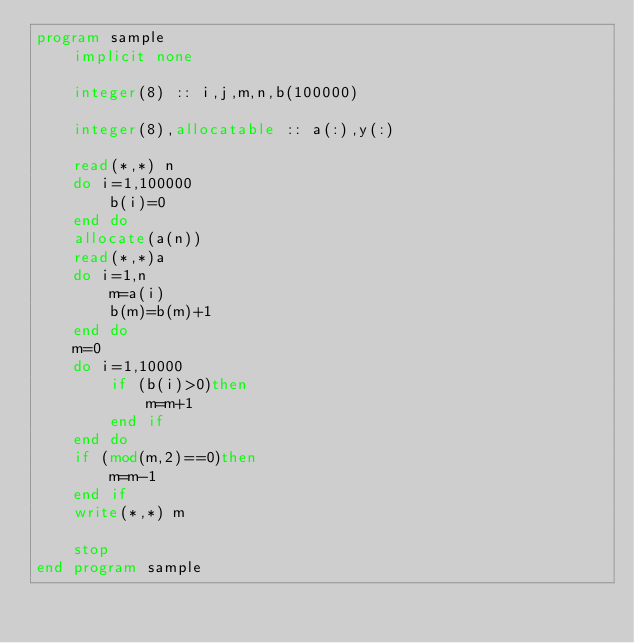<code> <loc_0><loc_0><loc_500><loc_500><_FORTRAN_>program sample
    implicit none
  
    integer(8) :: i,j,m,n,b(100000)
    
    integer(8),allocatable :: a(:),y(:)
  
    read(*,*) n
    do i=1,100000
        b(i)=0
    end do
    allocate(a(n))
    read(*,*)a
    do i=1,n
        m=a(i)
        b(m)=b(m)+1
    end do
    m=0
    do i=1,10000
        if (b(i)>0)then
            m=m+1
        end if
    end do
    if (mod(m,2)==0)then
        m=m-1
    end if
    write(*,*) m
  
    stop
end program sample
  

</code> 